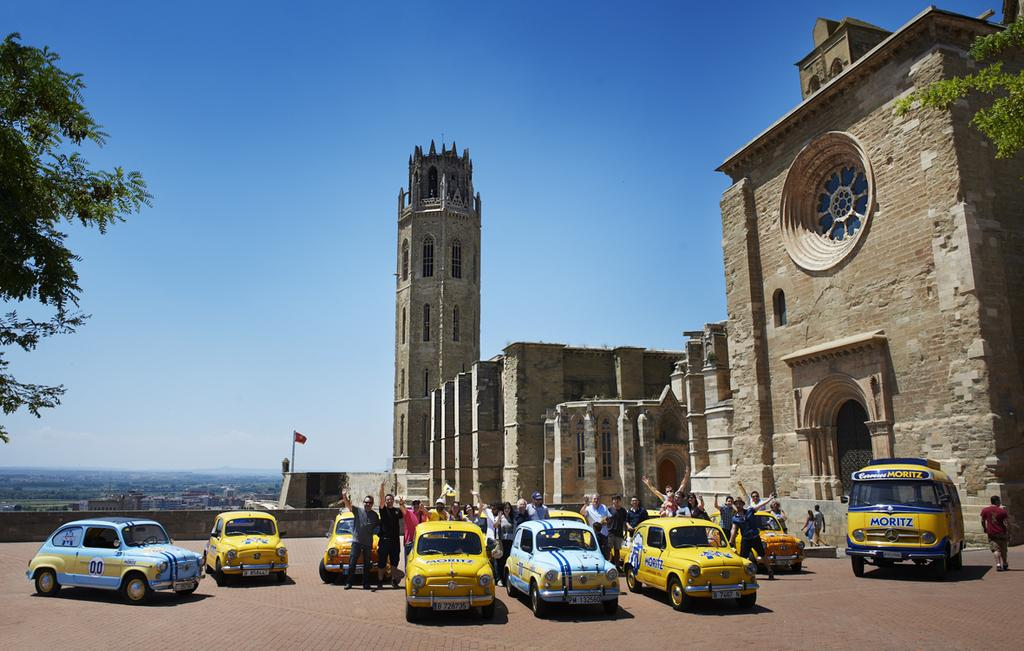<image>
Render a clear and concise summary of the photo. The company that is written all over the vehicles is Moritz 